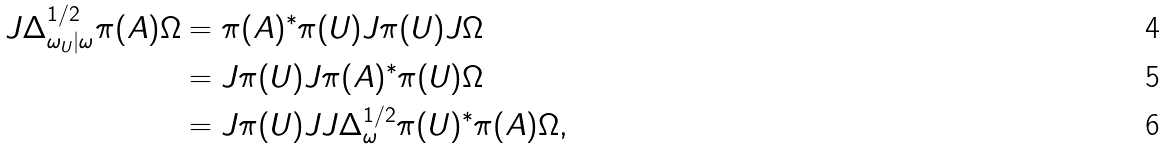Convert formula to latex. <formula><loc_0><loc_0><loc_500><loc_500>J \Delta _ { \omega _ { U } | \omega } ^ { 1 / 2 } \pi ( A ) \Omega & = \pi ( A ) ^ { \ast } \pi ( U ) J \pi ( U ) J \Omega \\ & = J \pi ( U ) J \pi ( A ) ^ { \ast } \pi ( U ) \Omega \\ & = J \pi ( U ) J J \Delta _ { \omega } ^ { 1 / 2 } \pi ( U ) ^ { \ast } \pi ( A ) \Omega ,</formula> 